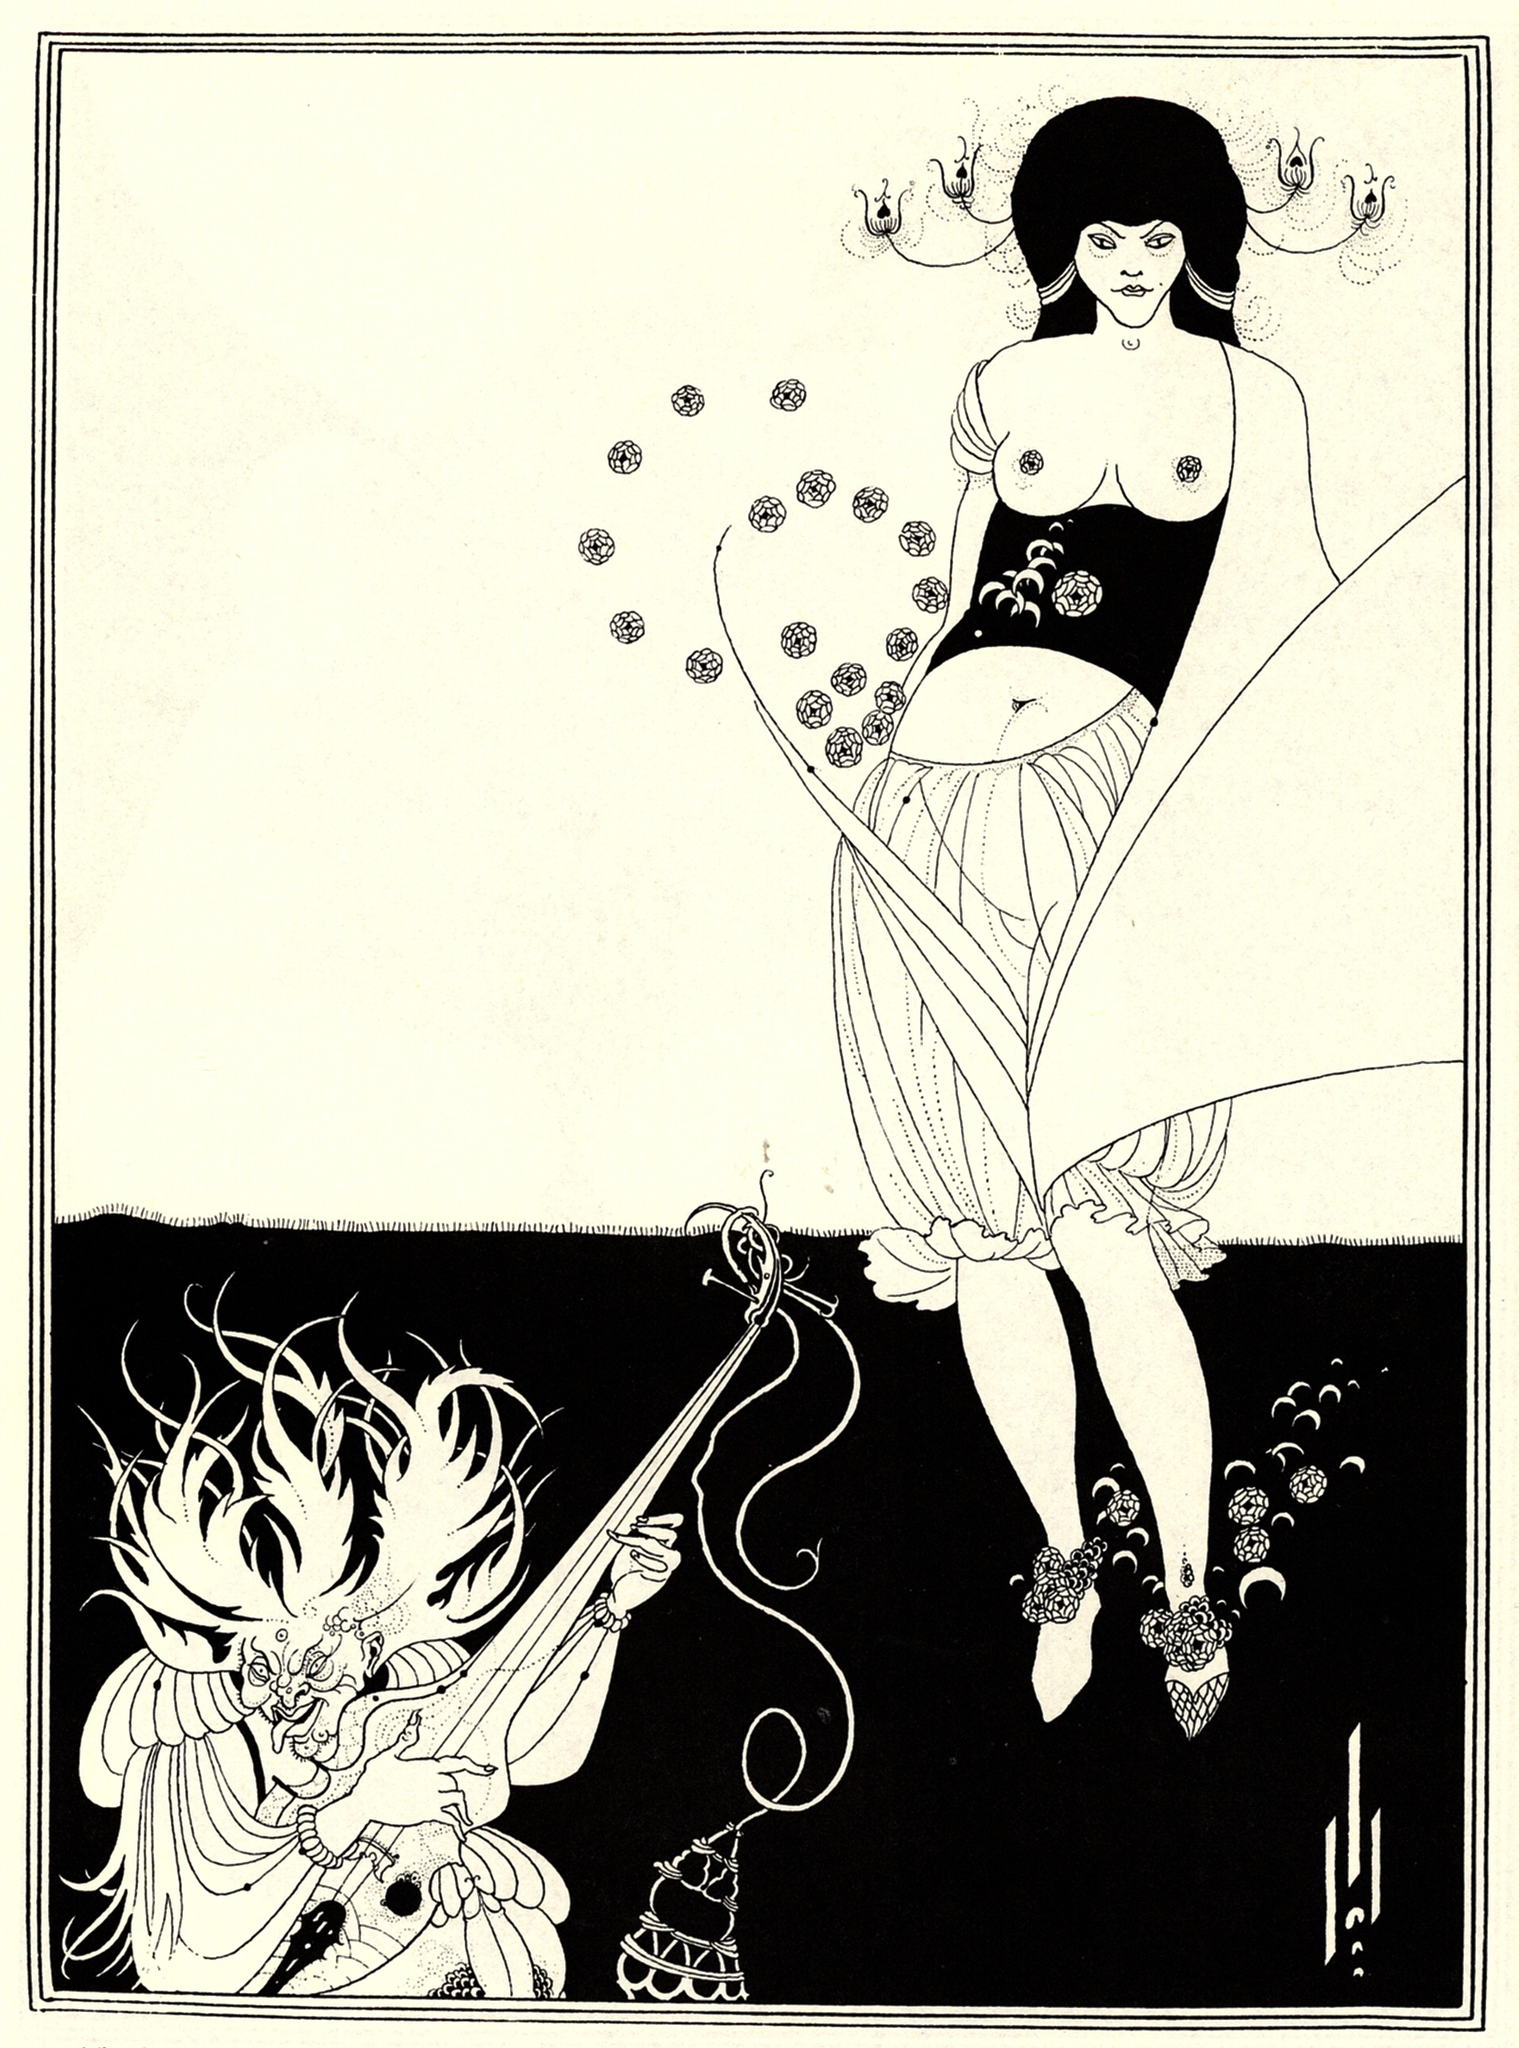What's happening in the scene? The scene depicted is a beautiful and intricate example of Art Nouveau design. In the illustration, a woman is prominently featured on the right side. She wears a long, flowing dress adorned with floral patterns, and her body is angled towards the viewer, although her head is turned to the left, presenting a profile view. She holds a long, thin object in her right hand, pointing it towards a figure on the left side. The left side of the image features a dragon, which adds a fantastical element to the scene. This dragon character holds a censer in its left hand and a sword in its right, amplifying the dramatic tension. Both the woman and the dragon are adorned with floral details, harmoniously tying the two figures together. The stark white background helps make the figures and their intricate details stand out, and a detailed border of black lines and dots frames the entire scene. 